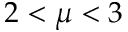<formula> <loc_0><loc_0><loc_500><loc_500>2 < \mu < 3</formula> 